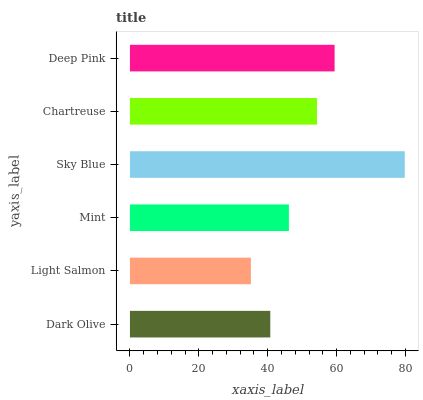Is Light Salmon the minimum?
Answer yes or no. Yes. Is Sky Blue the maximum?
Answer yes or no. Yes. Is Mint the minimum?
Answer yes or no. No. Is Mint the maximum?
Answer yes or no. No. Is Mint greater than Light Salmon?
Answer yes or no. Yes. Is Light Salmon less than Mint?
Answer yes or no. Yes. Is Light Salmon greater than Mint?
Answer yes or no. No. Is Mint less than Light Salmon?
Answer yes or no. No. Is Chartreuse the high median?
Answer yes or no. Yes. Is Mint the low median?
Answer yes or no. Yes. Is Sky Blue the high median?
Answer yes or no. No. Is Dark Olive the low median?
Answer yes or no. No. 